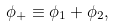Convert formula to latex. <formula><loc_0><loc_0><loc_500><loc_500>\phi _ { + } \equiv \phi _ { 1 } + \phi _ { 2 } ,</formula> 